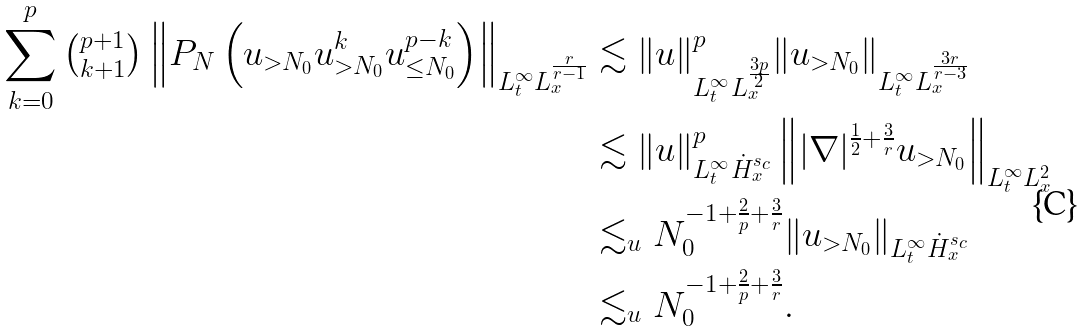Convert formula to latex. <formula><loc_0><loc_0><loc_500><loc_500>\sum _ { k = 0 } ^ { p } \tbinom { p + 1 } { k + 1 } \left \| P _ { N } \left ( u _ { > N _ { 0 } } u _ { > N _ { 0 } } ^ { k } u _ { \leq N _ { 0 } } ^ { p - k } \right ) \right \| _ { L _ { t } ^ { \infty } L _ { x } ^ { \frac { r } { r - 1 } } } & \lesssim \| u \| _ { L _ { t } ^ { \infty } L _ { x } ^ { \frac { 3 p } 2 } } ^ { p } \| u _ { > N _ { 0 } } \| _ { L _ { t } ^ { \infty } L _ { x } ^ { \frac { 3 r } { r - 3 } } } \\ & \lesssim \| u \| _ { L _ { t } ^ { \infty } \dot { H } ^ { s _ { c } } _ { x } } ^ { p } \left \| | \nabla | ^ { \frac { 1 } { 2 } + \frac { 3 } { r } } u _ { > N _ { 0 } } \right \| _ { L _ { t } ^ { \infty } L _ { x } ^ { 2 } } \\ & \lesssim _ { u } N _ { 0 } ^ { - 1 + \frac { 2 } { p } + \frac { 3 } { r } } \| u _ { > N _ { 0 } } \| _ { L _ { t } ^ { \infty } \dot { H } ^ { s _ { c } } _ { x } } \\ & \lesssim _ { u } N _ { 0 } ^ { - 1 + \frac { 2 } { p } + \frac { 3 } { r } } .</formula> 